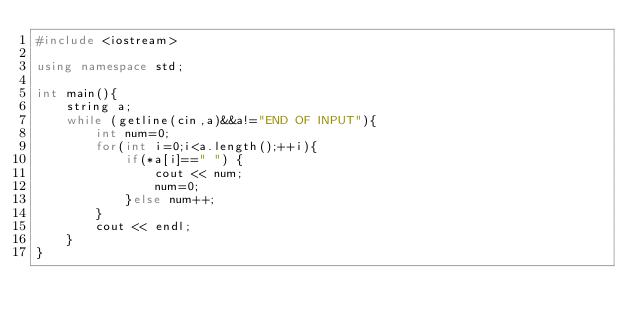<code> <loc_0><loc_0><loc_500><loc_500><_C++_>#include <iostream>

using namespace std;

int main(){
    string a;
    while (getline(cin,a)&&a!="END OF INPUT"){
        int num=0;
        for(int i=0;i<a.length();++i){
            if(*a[i]==" ") {
                cout << num;
                num=0;
            }else num++;
        }
        cout << endl;
    }
}
</code> 